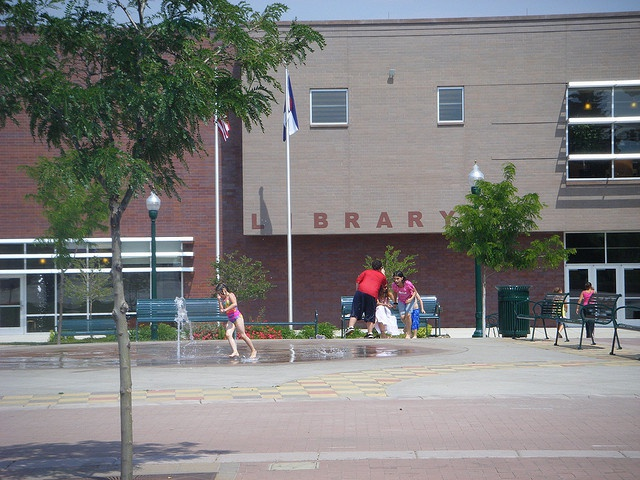Describe the objects in this image and their specific colors. I can see bench in black, blue, and gray tones, bench in black, gray, blue, and darkblue tones, people in black, salmon, brown, and navy tones, people in black, gray, brown, and purple tones, and people in black, lightgray, gray, and lightpink tones in this image. 